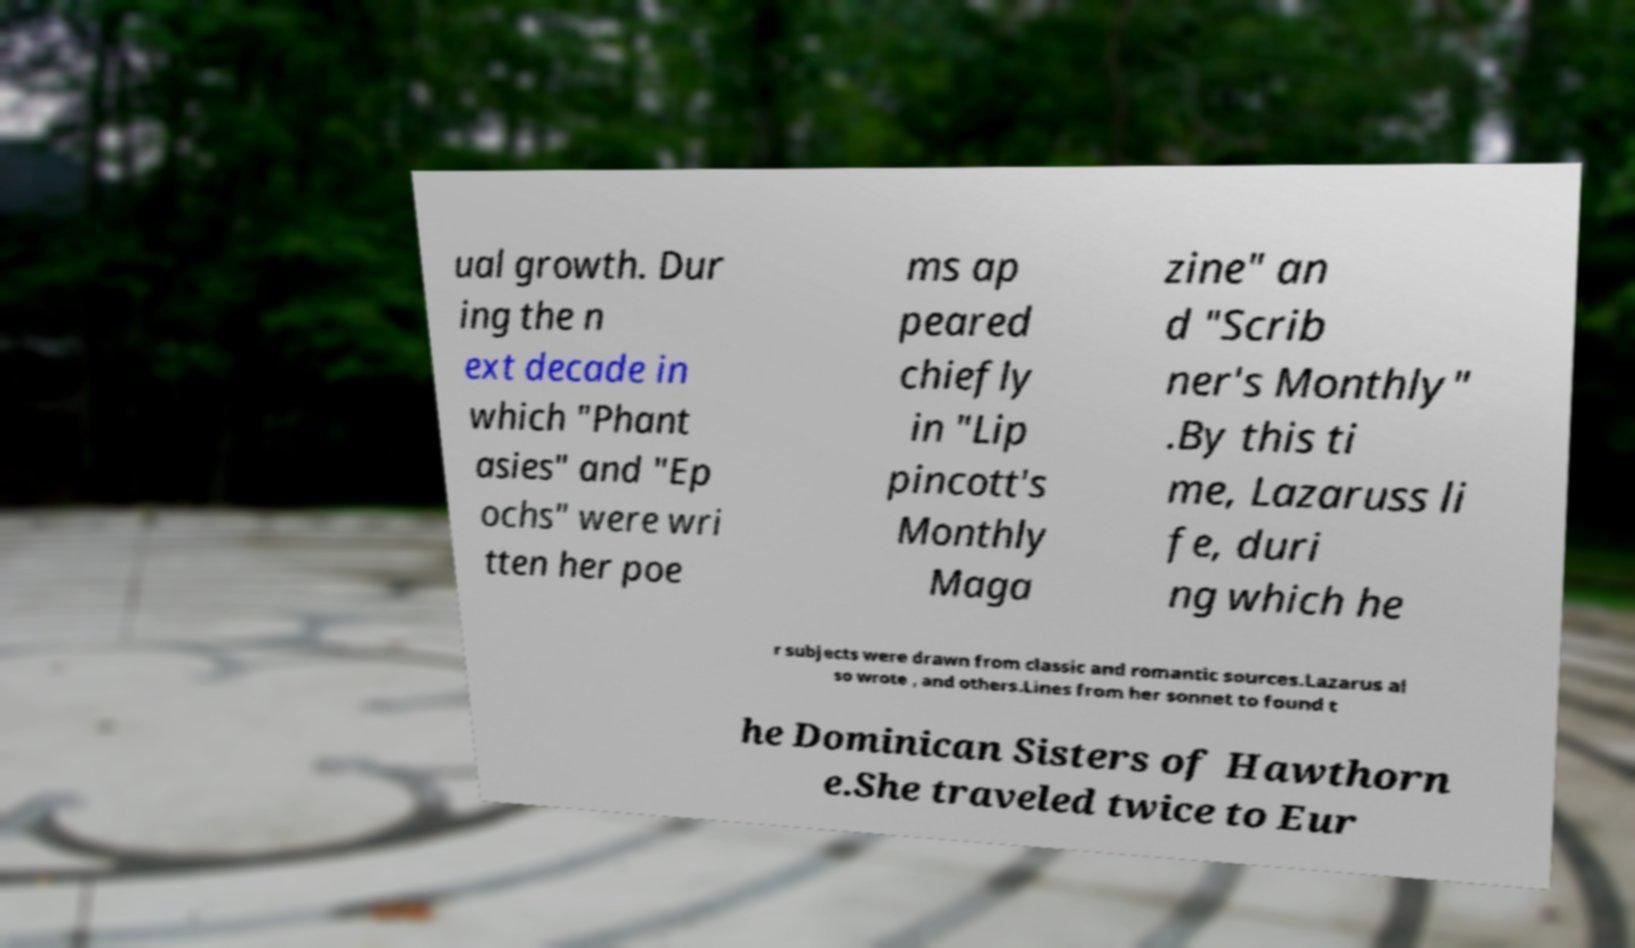Please read and relay the text visible in this image. What does it say? ual growth. Dur ing the n ext decade in which "Phant asies" and "Ep ochs" were wri tten her poe ms ap peared chiefly in "Lip pincott's Monthly Maga zine" an d "Scrib ner's Monthly" .By this ti me, Lazaruss li fe, duri ng which he r subjects were drawn from classic and romantic sources.Lazarus al so wrote , and others.Lines from her sonnet to found t he Dominican Sisters of Hawthorn e.She traveled twice to Eur 